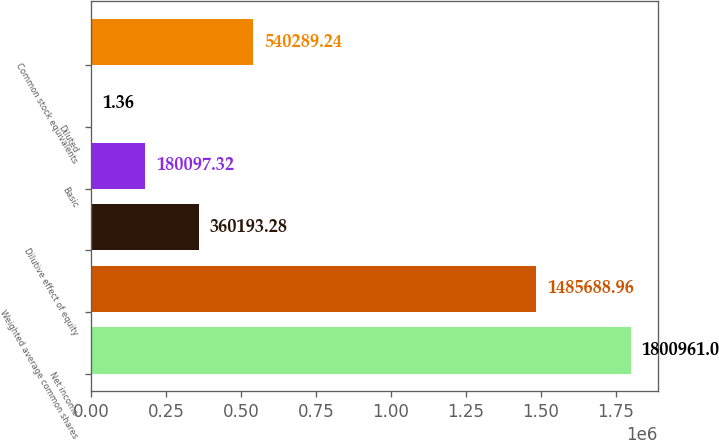<chart> <loc_0><loc_0><loc_500><loc_500><bar_chart><fcel>Net income<fcel>Weighted average common shares<fcel>Dilutive effect of equity<fcel>Basic<fcel>Diluted<fcel>Common stock equivalents<nl><fcel>1.80096e+06<fcel>1.48569e+06<fcel>360193<fcel>180097<fcel>1.36<fcel>540289<nl></chart> 